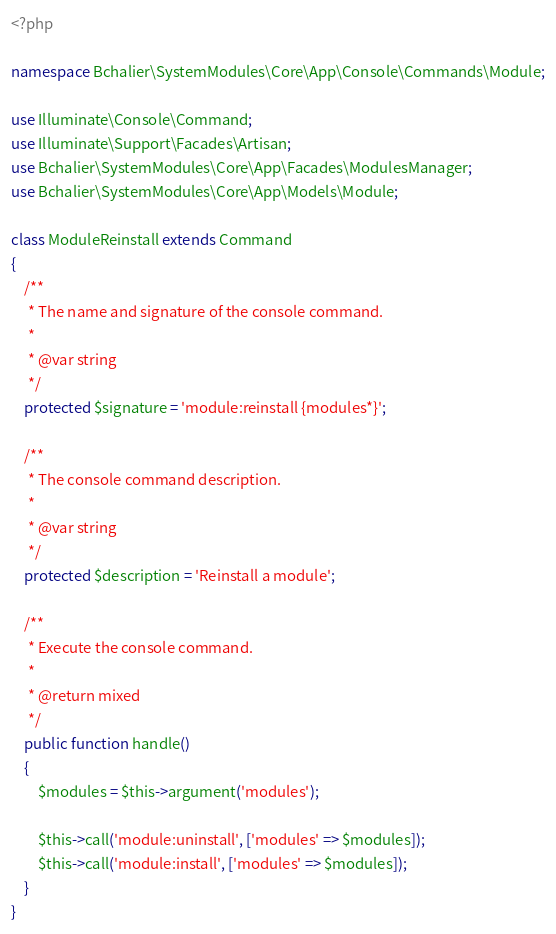Convert code to text. <code><loc_0><loc_0><loc_500><loc_500><_PHP_><?php

namespace Bchalier\SystemModules\Core\App\Console\Commands\Module;

use Illuminate\Console\Command;
use Illuminate\Support\Facades\Artisan;
use Bchalier\SystemModules\Core\App\Facades\ModulesManager;
use Bchalier\SystemModules\Core\App\Models\Module;

class ModuleReinstall extends Command
{
    /**
     * The name and signature of the console command.
     *
     * @var string
     */
    protected $signature = 'module:reinstall {modules*}';

    /**
     * The console command description.
     *
     * @var string
     */
    protected $description = 'Reinstall a module';

    /**
     * Execute the console command.
     *
     * @return mixed
     */
    public function handle()
    {
        $modules = $this->argument('modules');

        $this->call('module:uninstall', ['modules' => $modules]);
        $this->call('module:install', ['modules' => $modules]);
    }
}
</code> 